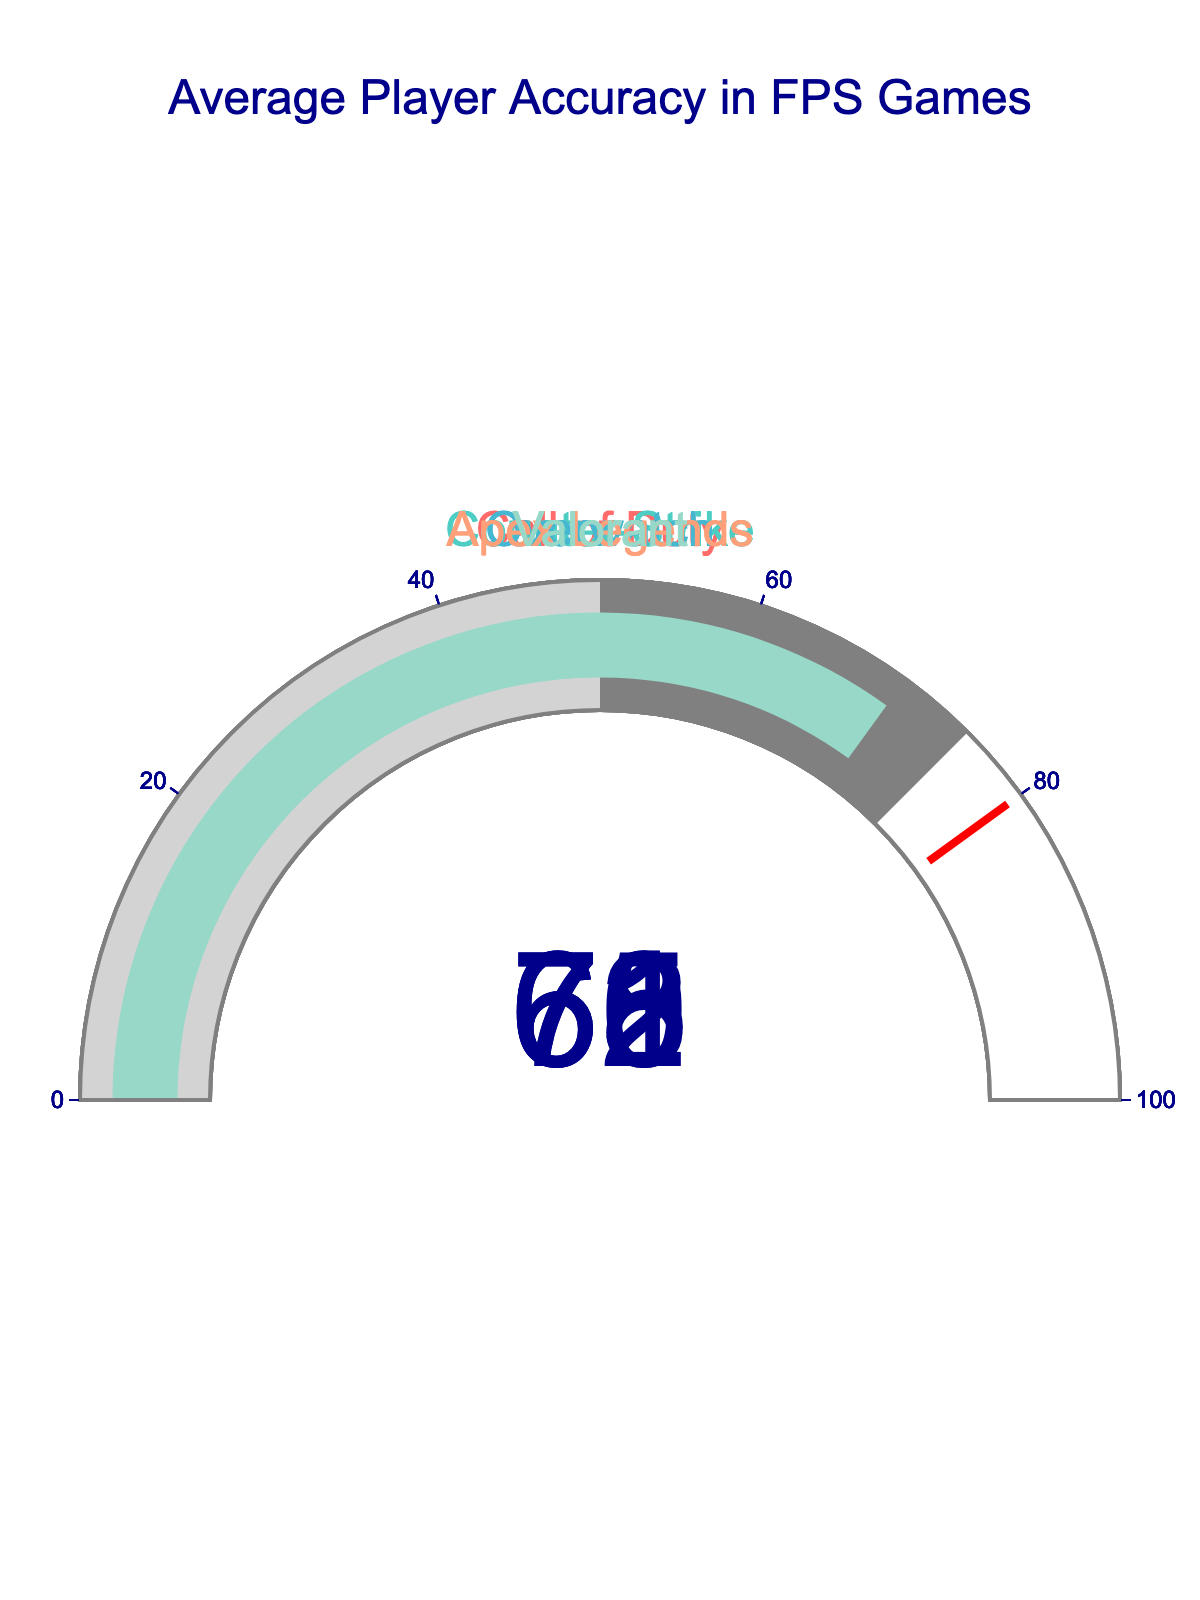What is the average player accuracy in Counter-Strike? The gauge chart for Counter-Strike indicates an accuracy value.
Answer: 72 Which game has the lowest average player accuracy? By checking the accuracy values in the gauge charts, the lowest value is found for Apex Legends.
Answer: Apex Legends How many games have an average player accuracy above 65? The accuracy values above 65 are for Call of Duty, Counter-Strike, and Valorant, resulting in three games.
Answer: 3 What is the difference in average player accuracy between Call of Duty and Overwatch? The accuracy values for Call of Duty and Overwatch are 68 and 65 respectively. The difference is calculated as 68 - 65.
Answer: 3 Which game has the highest average player accuracy? Observing all the gauge charts, Counter-Strike has the highest accuracy value.
Answer: Counter-Strike What is the combined average accuracy of Call of Duty and Counter-Strike? The accuracy values for Call of Duty and Counter-Strike are 68 and 72 respectively. Combine them (68+72) and find the average: (68 + 72) / 2.
Answer: 70 How many games have more than 70% accuracy? The only game with an accuracy value greater than 70 is Counter-Strike.
Answer: 1 Is the average player accuracy for Valorant closer to Call of Duty or Overwatch? Valorant's accuracy is 70, Call of Duty is 68, and Overwatch is 65. The difference between Valorant and Call of Duty is 2, and between Valorant and Overwatch is 5.
Answer: Call of Duty What is the range of average accuracies in these games? The highest accuracy is 72 (Counter-Strike) and the lowest is 61 (Apex Legends). The range is calculated as 72 - 61.
Answer: 11 